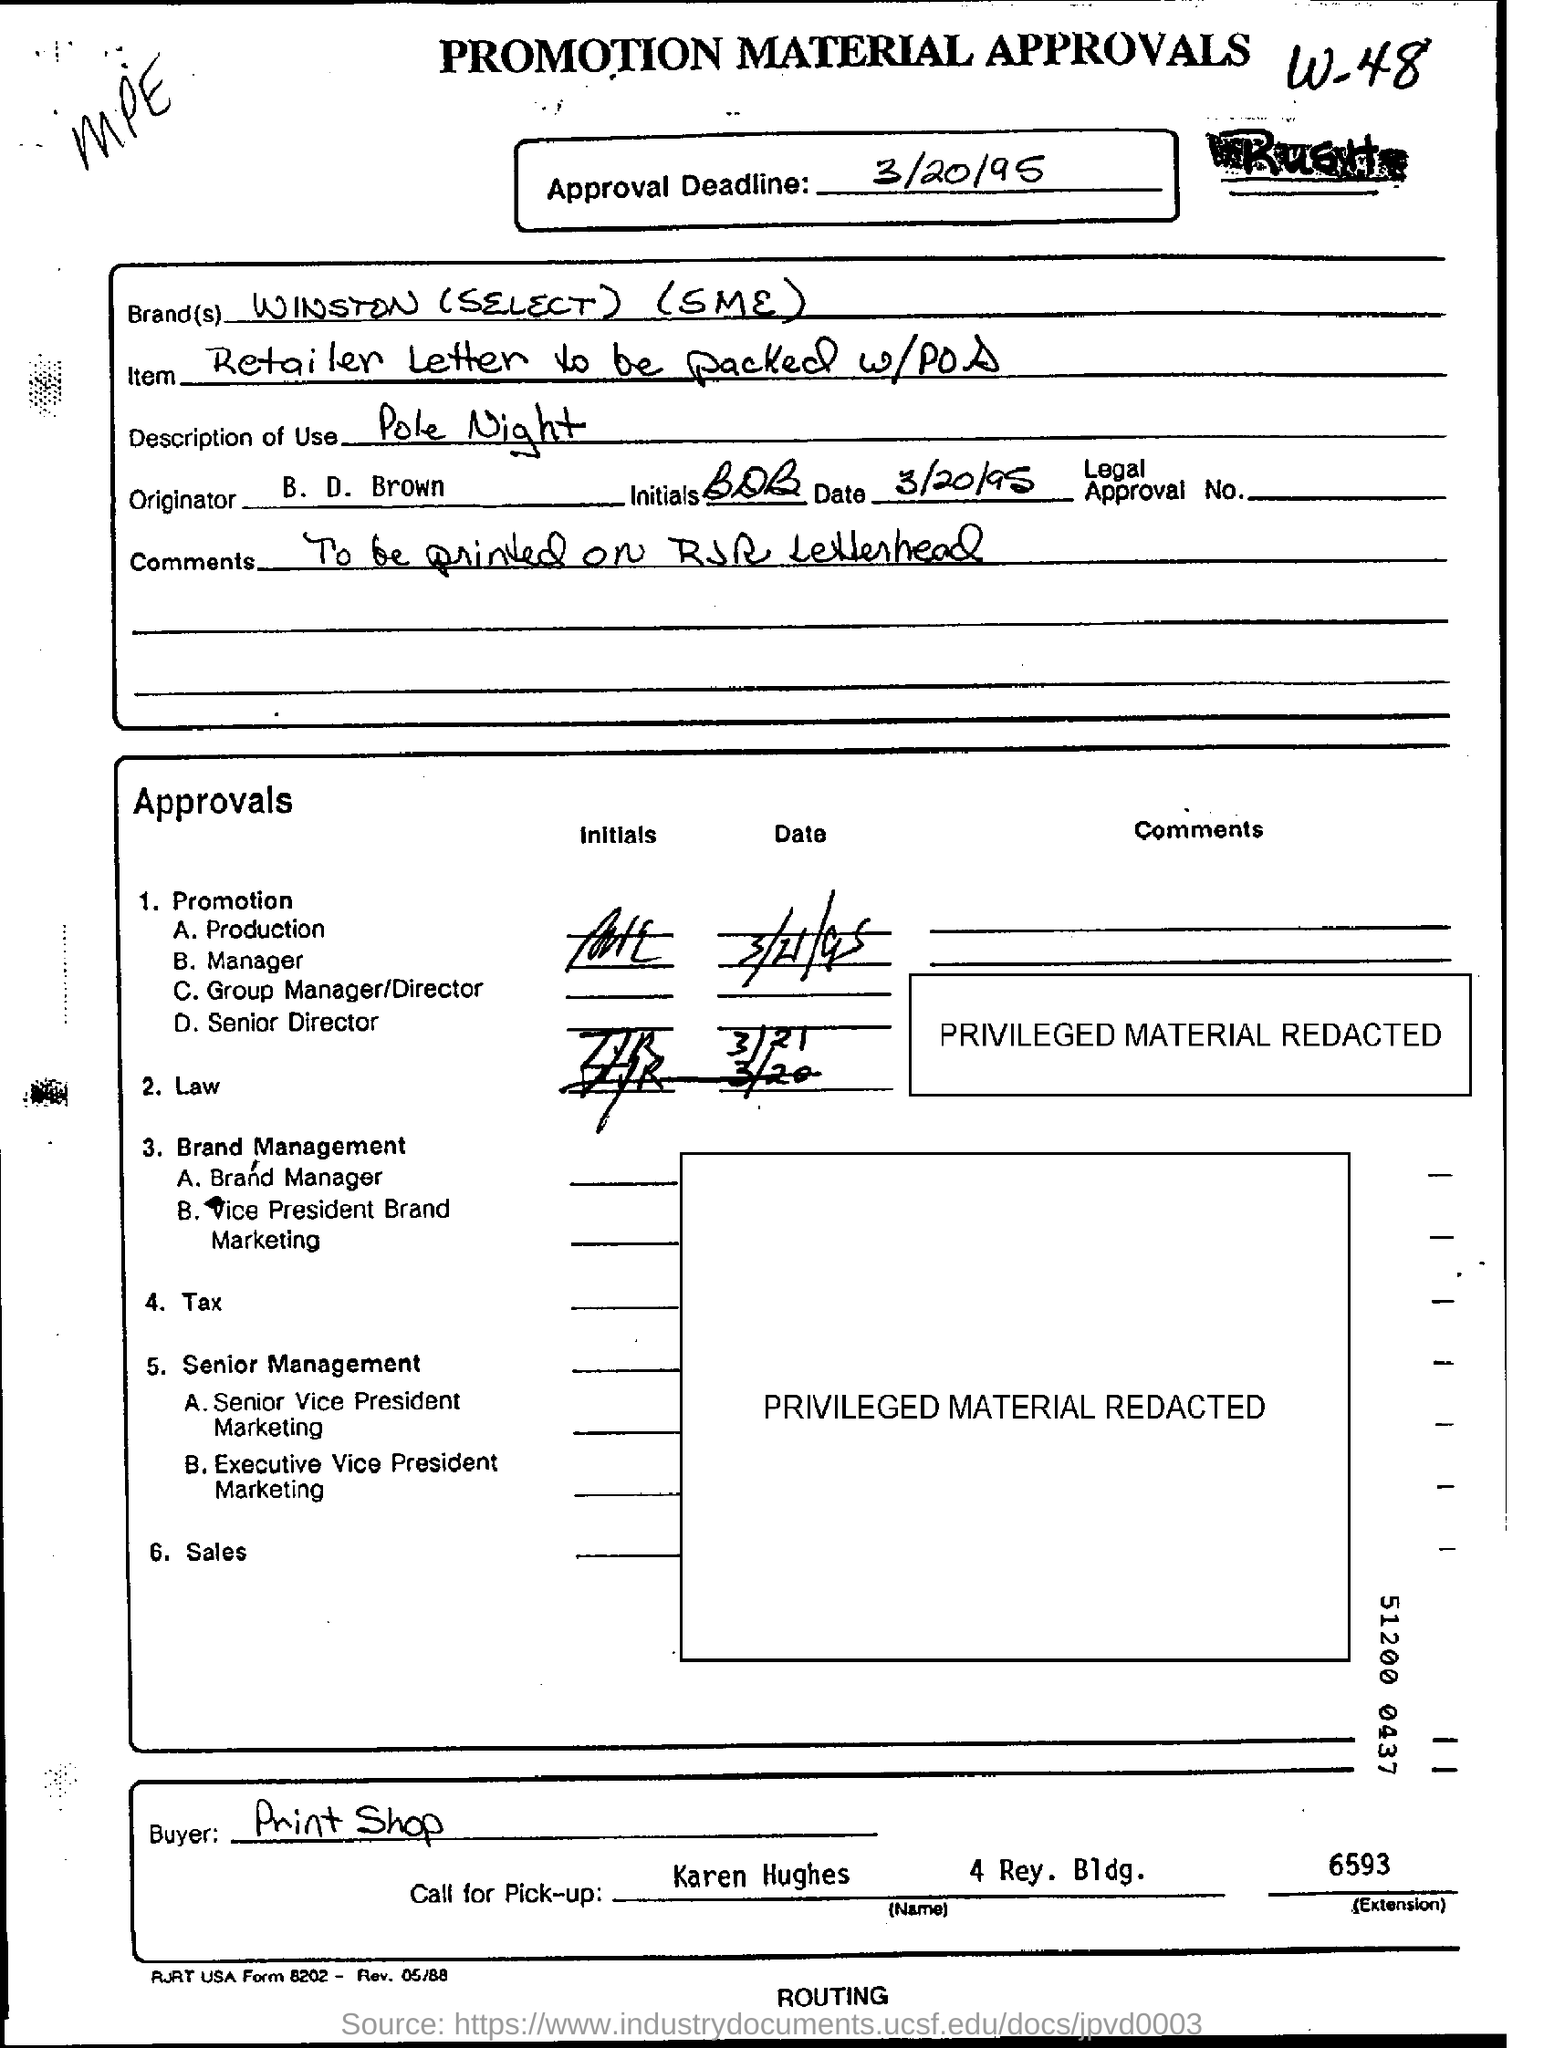Give some essential details in this illustration. B. D. Brown is the originator. The approval deadline is March 20, 1995. The item mentioned in the retailer letter should be packed with the point of sale (POS) device. The information provided in the comments should be printed on RJR letterhead. The Print Shop is the buyer in this scenario. 